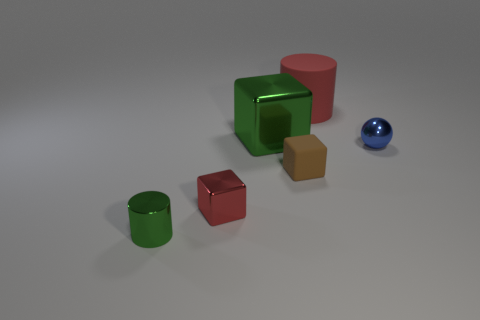Add 2 tiny brown matte objects. How many objects exist? 8 Subtract all cylinders. How many objects are left? 4 Add 3 matte blocks. How many matte blocks are left? 4 Add 2 small cylinders. How many small cylinders exist? 3 Subtract 0 blue cylinders. How many objects are left? 6 Subtract all tiny brown metallic objects. Subtract all tiny shiny things. How many objects are left? 3 